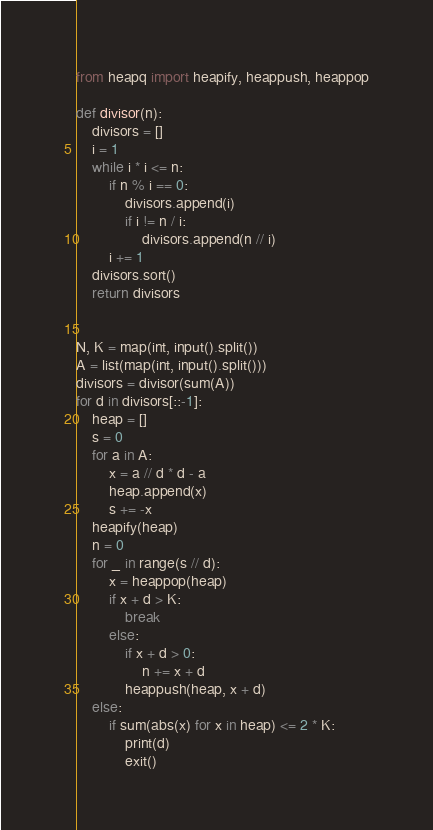Convert code to text. <code><loc_0><loc_0><loc_500><loc_500><_Python_>from heapq import heapify, heappush, heappop

def divisor(n):
    divisors = []
    i = 1
    while i * i <= n:
        if n % i == 0:
            divisors.append(i)
            if i != n / i:
                divisors.append(n // i)
        i += 1
    divisors.sort()
    return divisors


N, K = map(int, input().split())
A = list(map(int, input().split()))
divisors = divisor(sum(A))
for d in divisors[::-1]:
    heap = []
    s = 0
    for a in A:
        x = a // d * d - a
        heap.append(x)
        s += -x
    heapify(heap)
    n = 0
    for _ in range(s // d):
        x = heappop(heap)
        if x + d > K:
            break
        else:
            if x + d > 0:
                n += x + d
            heappush(heap, x + d)
    else:
        if sum(abs(x) for x in heap) <= 2 * K:
            print(d)
            exit()
</code> 